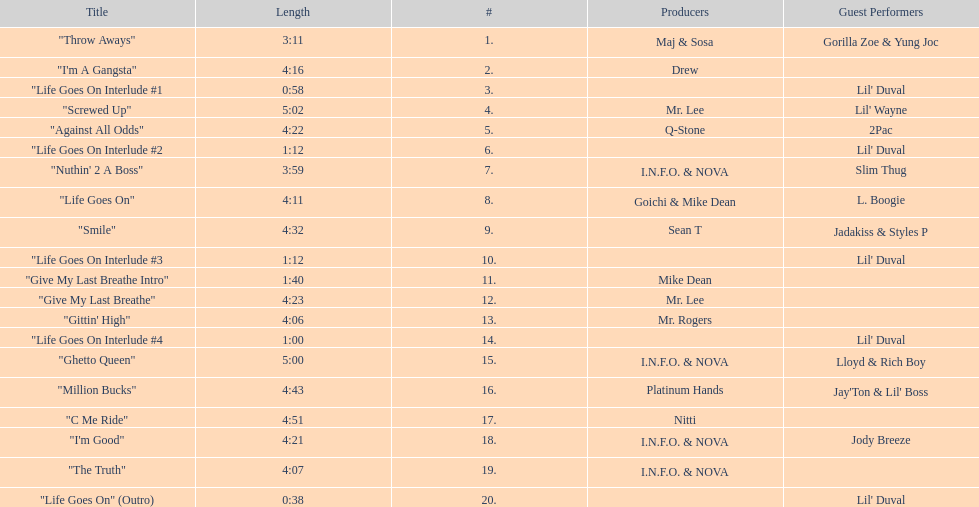How long is track number 11? 1:40. 